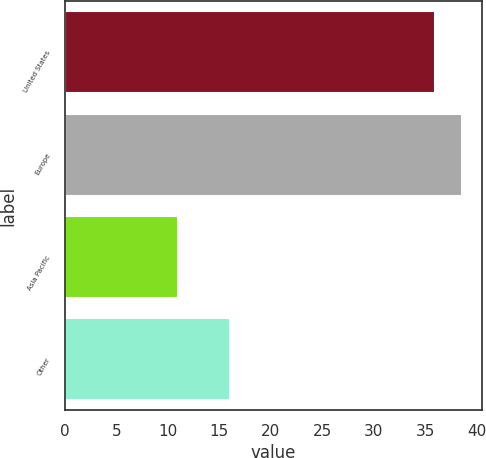Convert chart. <chart><loc_0><loc_0><loc_500><loc_500><bar_chart><fcel>United States<fcel>Europe<fcel>Asia Pacific<fcel>Other<nl><fcel>36<fcel>38.6<fcel>11<fcel>16<nl></chart> 